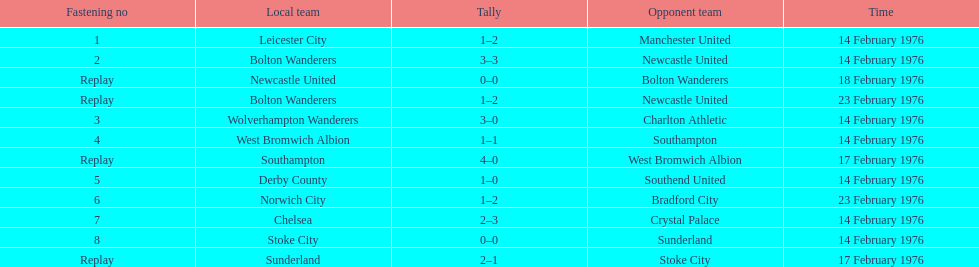How many games were replays? 4. 